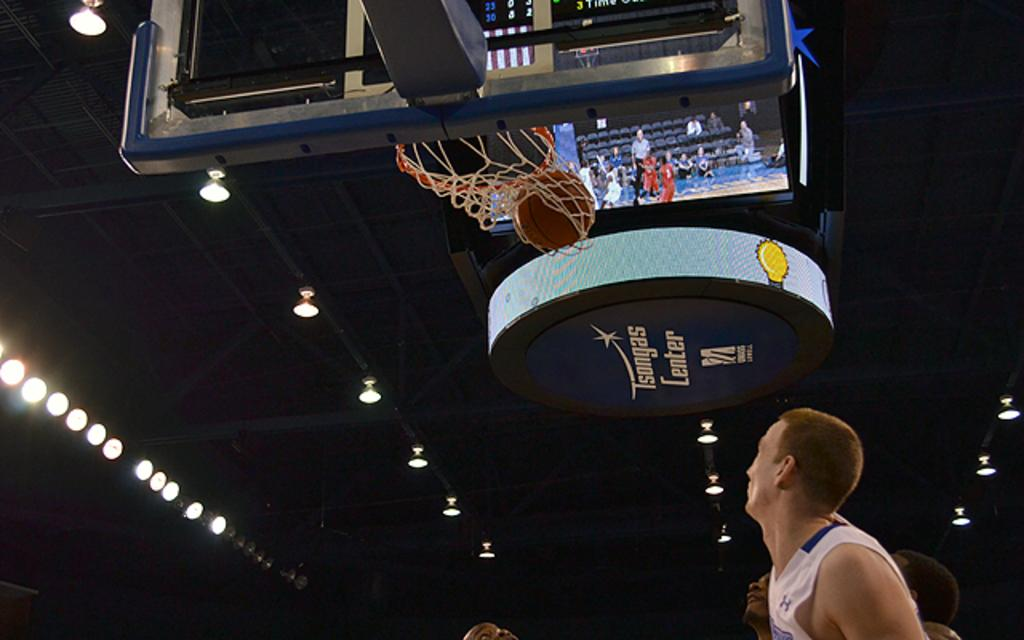<image>
Relay a brief, clear account of the picture shown. The ball goes in the net inside Tsongas Center. 